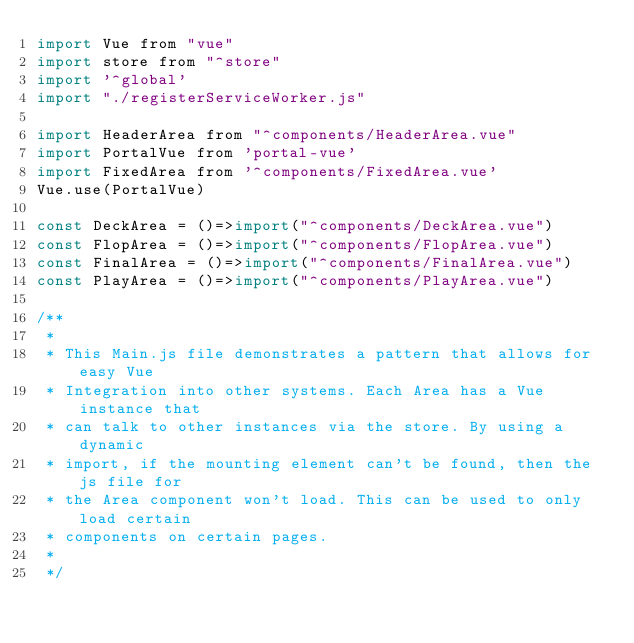Convert code to text. <code><loc_0><loc_0><loc_500><loc_500><_JavaScript_>import Vue from "vue"
import store from "^store"
import '^global'
import "./registerServiceWorker.js"

import HeaderArea from "^components/HeaderArea.vue"
import PortalVue from 'portal-vue'
import FixedArea from '^components/FixedArea.vue'
Vue.use(PortalVue)

const DeckArea = ()=>import("^components/DeckArea.vue")
const FlopArea = ()=>import("^components/FlopArea.vue")
const FinalArea = ()=>import("^components/FinalArea.vue")
const PlayArea = ()=>import("^components/PlayArea.vue")

/**
 *
 * This Main.js file demonstrates a pattern that allows for easy Vue
 * Integration into other systems. Each Area has a Vue instance that
 * can talk to other instances via the store. By using a dynamic
 * import, if the mounting element can't be found, then the js file for
 * the Area component won't load. This can be used to only load certain
 * components on certain pages.
 *
 */
</code> 